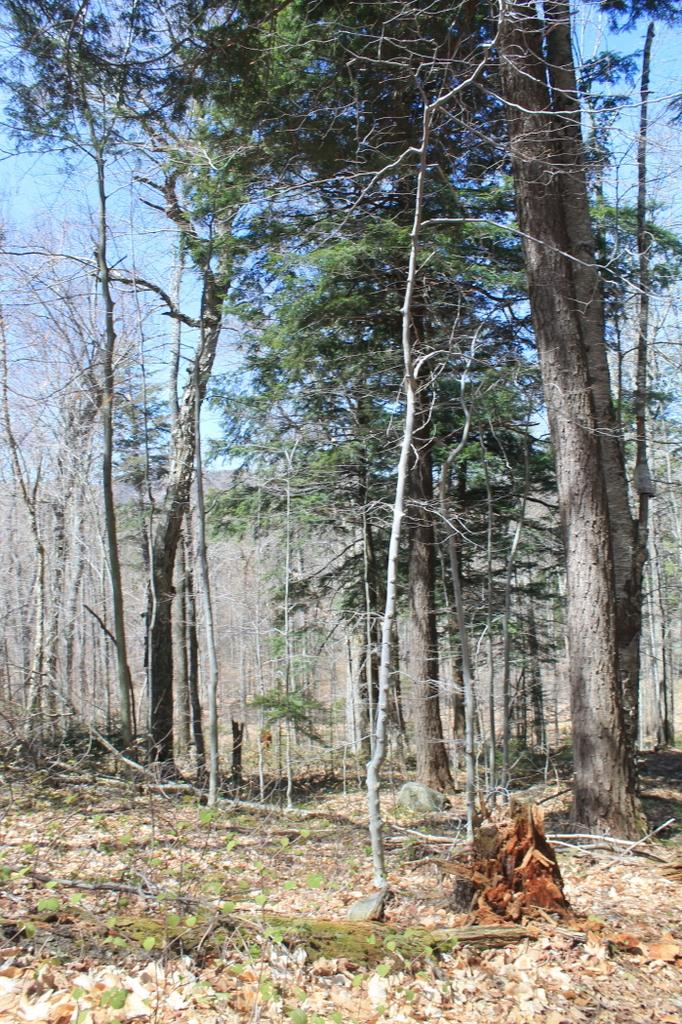What is on the ground in the image? There are dried leaves on the ground in the image. What type of vegetation is present in the image? There are trees in the image. What can be seen at the top of the image? The sky is visible at the top of the image, and it appears to be blue. How does the van drive through the dried leaves in the image? There is no van present in the image; it only features dried leaves on the ground and trees. What type of breath can be seen coming from the trees in the image? There is no breath visible in the image, as trees do not have the ability to breathe. 